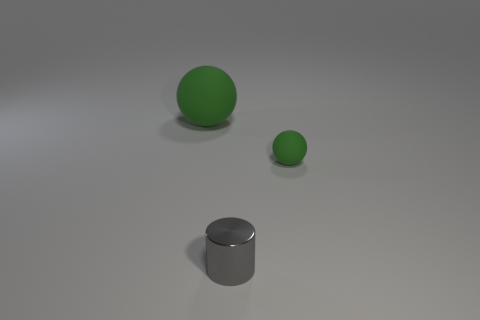Is the color of the large object the same as the small rubber ball?
Your answer should be compact. Yes. Are there any other things that are made of the same material as the tiny cylinder?
Keep it short and to the point. No. Are there any other things that have the same color as the tiny metal object?
Your response must be concise. No. The rubber sphere in front of the green ball that is left of the tiny gray shiny thing is what color?
Offer a terse response. Green. The tiny gray cylinder right of the rubber object that is to the left of the small thing behind the gray shiny cylinder is made of what material?
Offer a terse response. Metal. How many matte balls have the same size as the gray cylinder?
Keep it short and to the point. 1. What is the material of the object that is both on the right side of the large rubber thing and behind the small gray thing?
Keep it short and to the point. Rubber. There is a metal object; how many small gray things are to the left of it?
Your answer should be very brief. 0. Does the big thing have the same shape as the green object that is on the right side of the tiny metal cylinder?
Your answer should be very brief. Yes. Are there any small rubber objects that have the same shape as the large matte thing?
Ensure brevity in your answer.  Yes. 